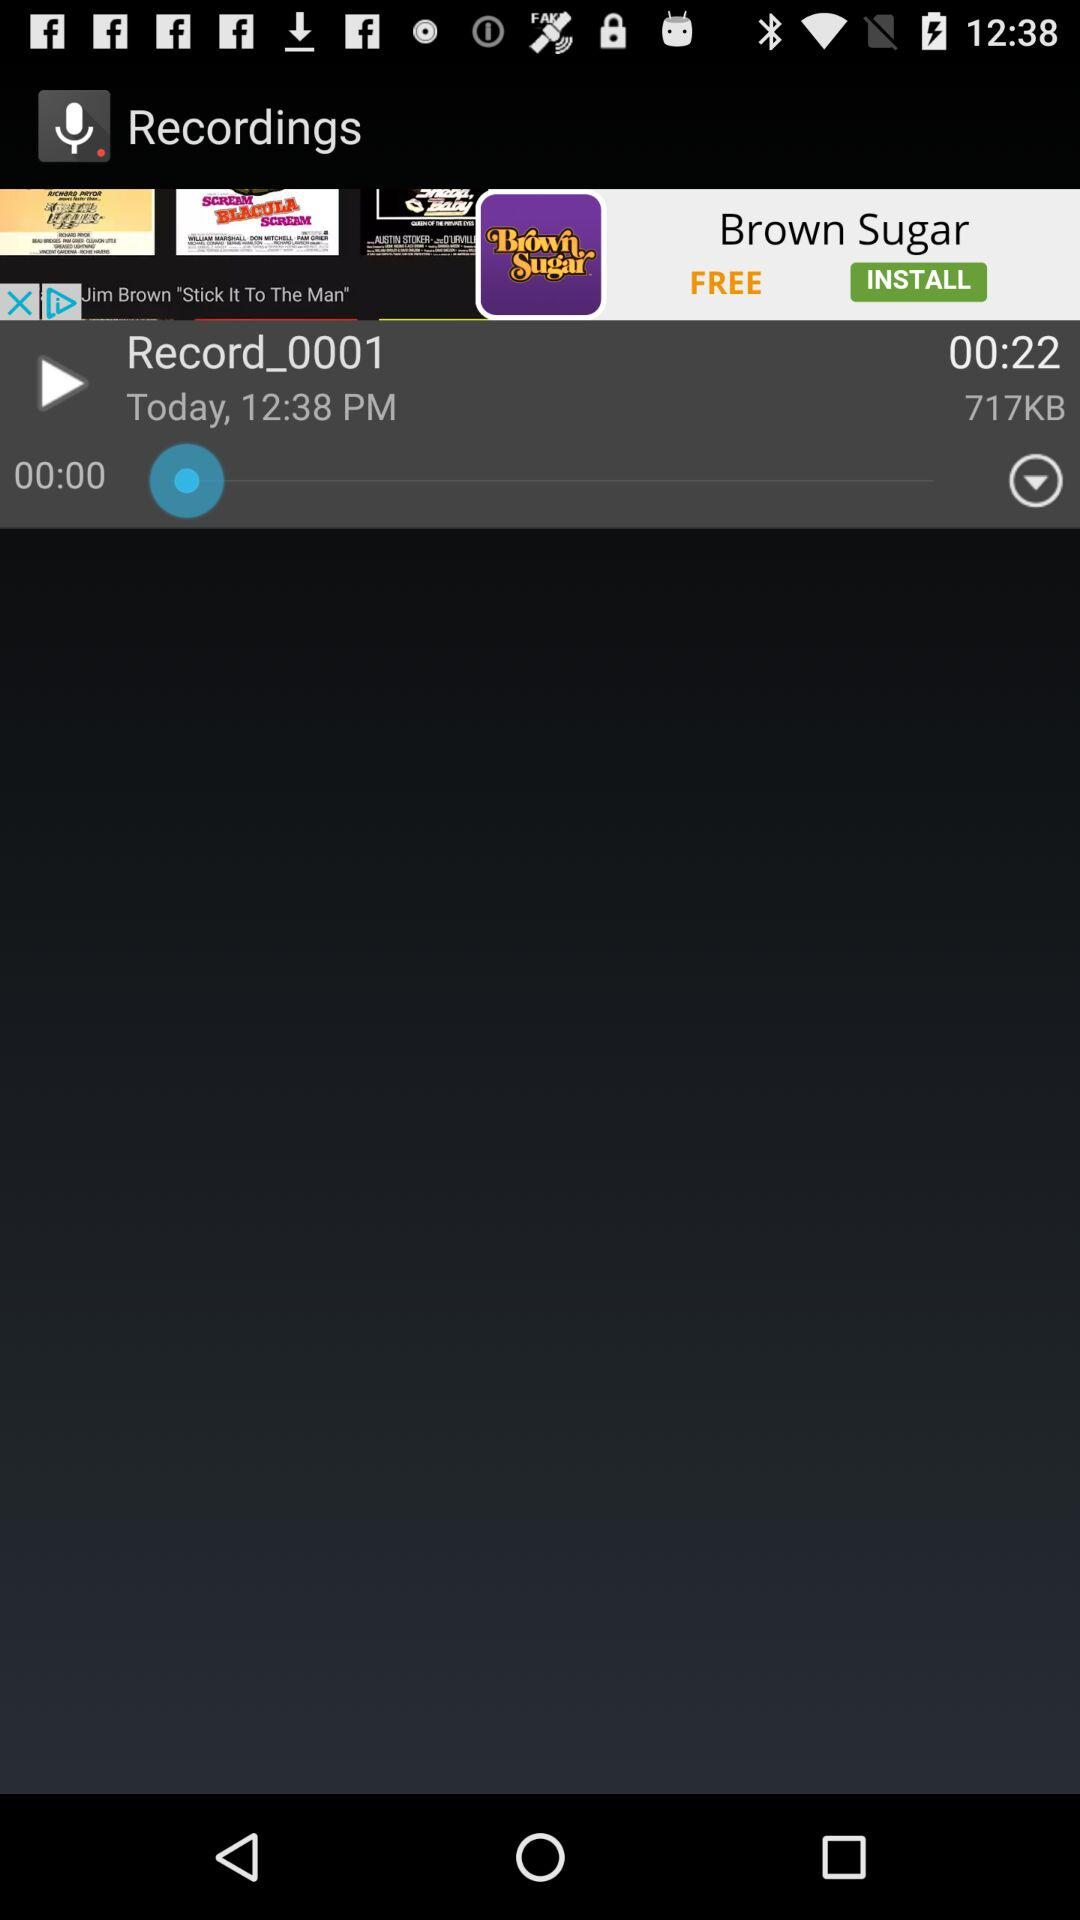What is the time of the recording? The time of the recording is 12:38 PM. 